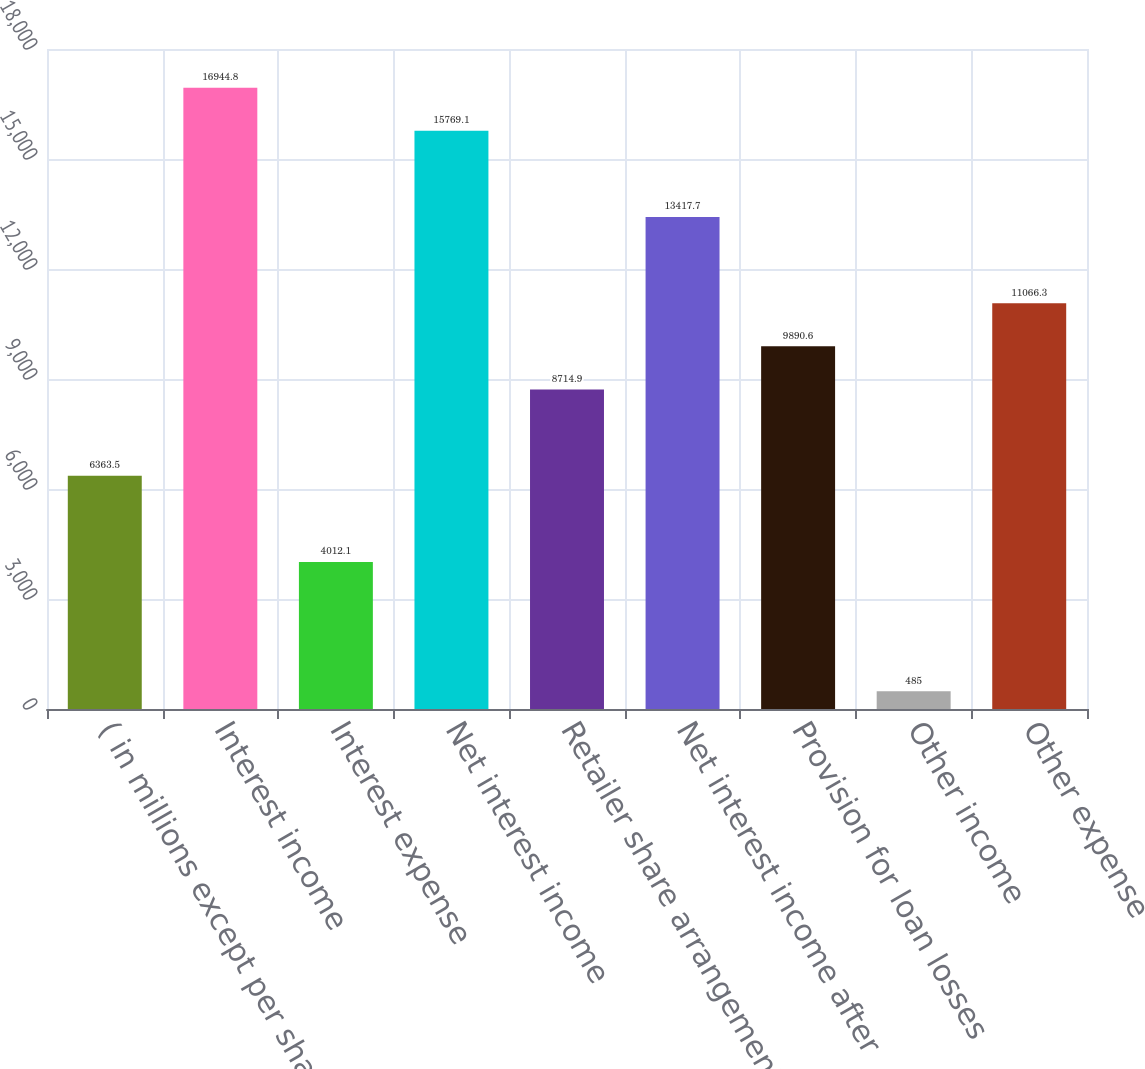<chart> <loc_0><loc_0><loc_500><loc_500><bar_chart><fcel>( in millions except per share<fcel>Interest income<fcel>Interest expense<fcel>Net interest income<fcel>Retailer share arrangements<fcel>Net interest income after<fcel>Provision for loan losses<fcel>Other income<fcel>Other expense<nl><fcel>6363.5<fcel>16944.8<fcel>4012.1<fcel>15769.1<fcel>8714.9<fcel>13417.7<fcel>9890.6<fcel>485<fcel>11066.3<nl></chart> 